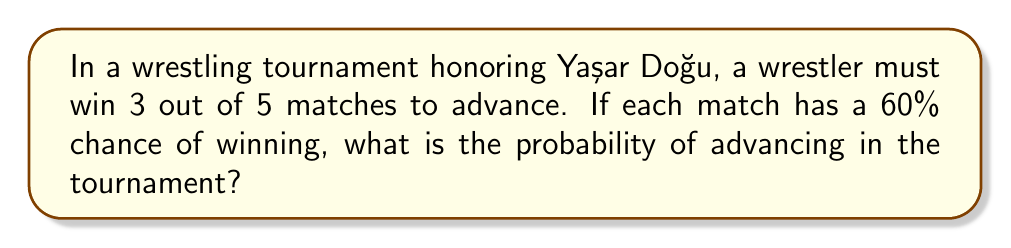Give your solution to this math problem. Let's approach this step-by-step:

1) We need to find the probability of winning at least 3 out of 5 matches.

2) This can be calculated by summing the probabilities of winning exactly 3, 4, or 5 matches.

3) We can use the binomial probability formula:

   $P(X = k) = \binom{n}{k} p^k (1-p)^{n-k}$

   Where $n$ is the number of trials, $k$ is the number of successes, $p$ is the probability of success on each trial.

4) In this case, $n = 5$, $p = 0.6$, and we need to calculate for $k = 3$, $4$, and $5$.

5) For $k = 3$:
   $P(X = 3) = \binom{5}{3} (0.6)^3 (0.4)^2 = 10 \cdot 0.216 \cdot 0.16 = 0.3456$

6) For $k = 4$:
   $P(X = 4) = \binom{5}{4} (0.6)^4 (0.4)^1 = 5 \cdot 0.1296 \cdot 0.4 = 0.2592$

7) For $k = 5$:
   $P(X = 5) = \binom{5}{5} (0.6)^5 (0.4)^0 = 1 \cdot 0.07776 \cdot 1 = 0.07776$

8) The total probability is the sum of these:
   $P(\text{advancing}) = 0.3456 + 0.2592 + 0.07776 = 0.68256$
Answer: $0.68256$ or approximately $68.26\%$ 